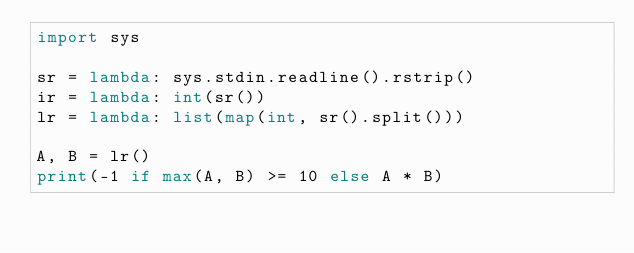Convert code to text. <code><loc_0><loc_0><loc_500><loc_500><_Python_>import sys

sr = lambda: sys.stdin.readline().rstrip()
ir = lambda: int(sr())
lr = lambda: list(map(int, sr().split()))

A, B = lr()
print(-1 if max(A, B) >= 10 else A * B)
</code> 